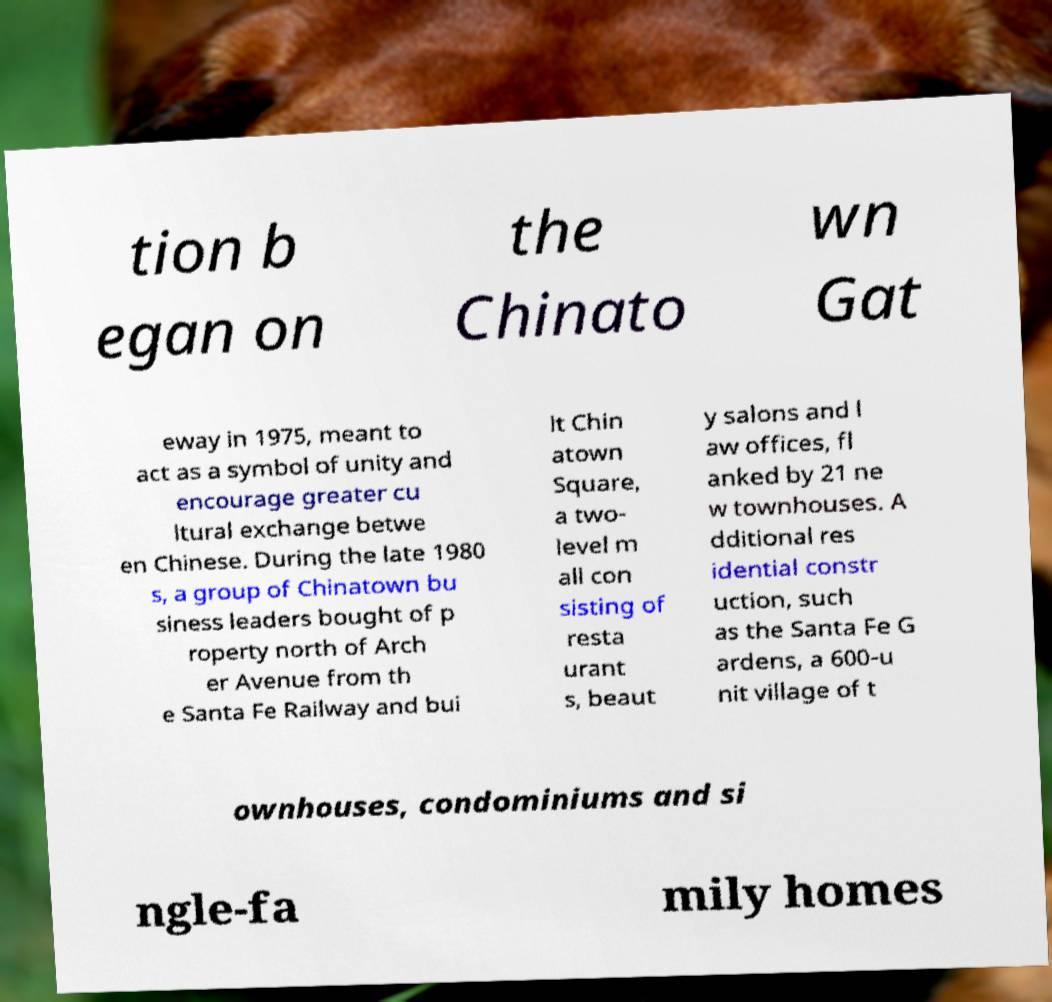For documentation purposes, I need the text within this image transcribed. Could you provide that? tion b egan on the Chinato wn Gat eway in 1975, meant to act as a symbol of unity and encourage greater cu ltural exchange betwe en Chinese. During the late 1980 s, a group of Chinatown bu siness leaders bought of p roperty north of Arch er Avenue from th e Santa Fe Railway and bui lt Chin atown Square, a two- level m all con sisting of resta urant s, beaut y salons and l aw offices, fl anked by 21 ne w townhouses. A dditional res idential constr uction, such as the Santa Fe G ardens, a 600-u nit village of t ownhouses, condominiums and si ngle-fa mily homes 